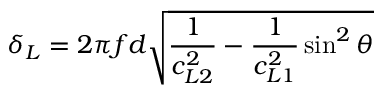Convert formula to latex. <formula><loc_0><loc_0><loc_500><loc_500>\delta _ { L } = 2 \pi f d \sqrt { \frac { 1 } { c _ { L 2 } ^ { 2 } } - \frac { 1 } { c _ { L 1 } ^ { 2 } } \sin ^ { 2 } \theta }</formula> 